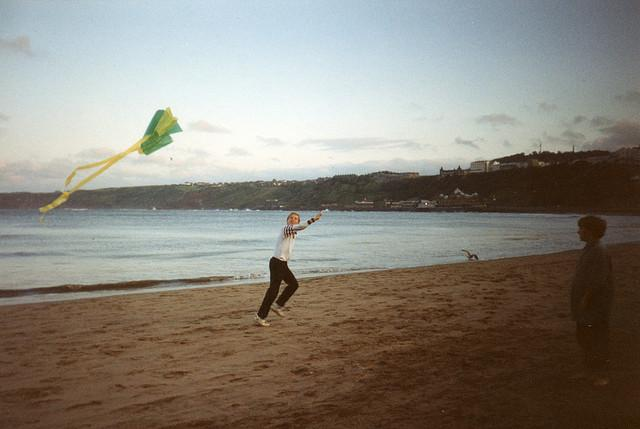Where is the kite in relation to the boy?

Choices:
A) under
B) in front
C) behind
D) invisible behind 